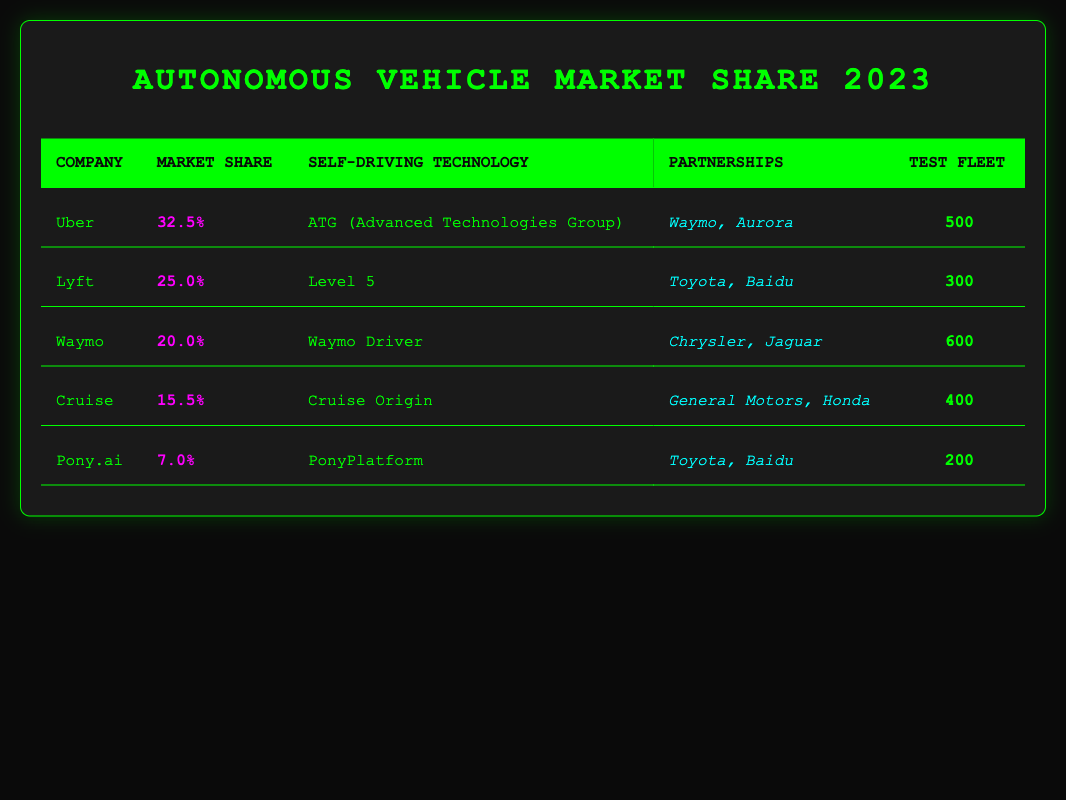What is Uber's market share? The table shows that Uber has a market share of 32.5%.
Answer: 32.5% Which company has the most vehicles in its test fleet? According to the table, Waymo has the most vehicles in its test fleet with 600 vehicles.
Answer: Waymo How many vehicles are in Lyft's test fleet? The table indicates that Lyft has 300 vehicles in its test fleet.
Answer: 300 Is Pony.ai's market share greater than 10%? The table shows that Pony.ai has a market share of 7.0%, which is less than 10%.
Answer: No Which two companies have partnerships with Toyota? From the table, both Lyft and Pony.ai have partnerships with Toyota.
Answer: Lyft and Pony.ai What is the total market share of Uber and Lyft combined? Uber's market share is 32.5%, and Lyft's market share is 25.0%. Adding these two gives 32.5 + 25.0 = 57.5%.
Answer: 57.5% Which company has the second highest market share? The table indicates that Lyft has the second highest market share at 25.0%, following Uber.
Answer: Lyft If we compare the market shares of Cruise and Waymo, which one is larger? Cruise has a market share of 15.5% and Waymo has 20.0%. Since 20.0% is greater than 15.5%, Waymo has a larger market share.
Answer: Waymo What is the average number of vehicles in the test fleets of all listed companies? The number of vehicles in the test fleets are 500 (Uber), 300 (Lyft), 600 (Waymo), 400 (Cruise), and 200 (Pony.ai), which adds up to 500 + 300 + 600 + 400 + 200 = 2000. There are 5 companies, so the average is 2000 / 5 = 400.
Answer: 400 Does Waymo have partnerships with any electric vehicle manufacturers? Waymo's partnerships listed are Chrysler and Jaguar, and both are known for traditional vehicles and luxury cars but not specifically electric vehicles. Therefore, it can be concluded that Waymo does not have partnerships with electric vehicle manufacturers.
Answer: No 